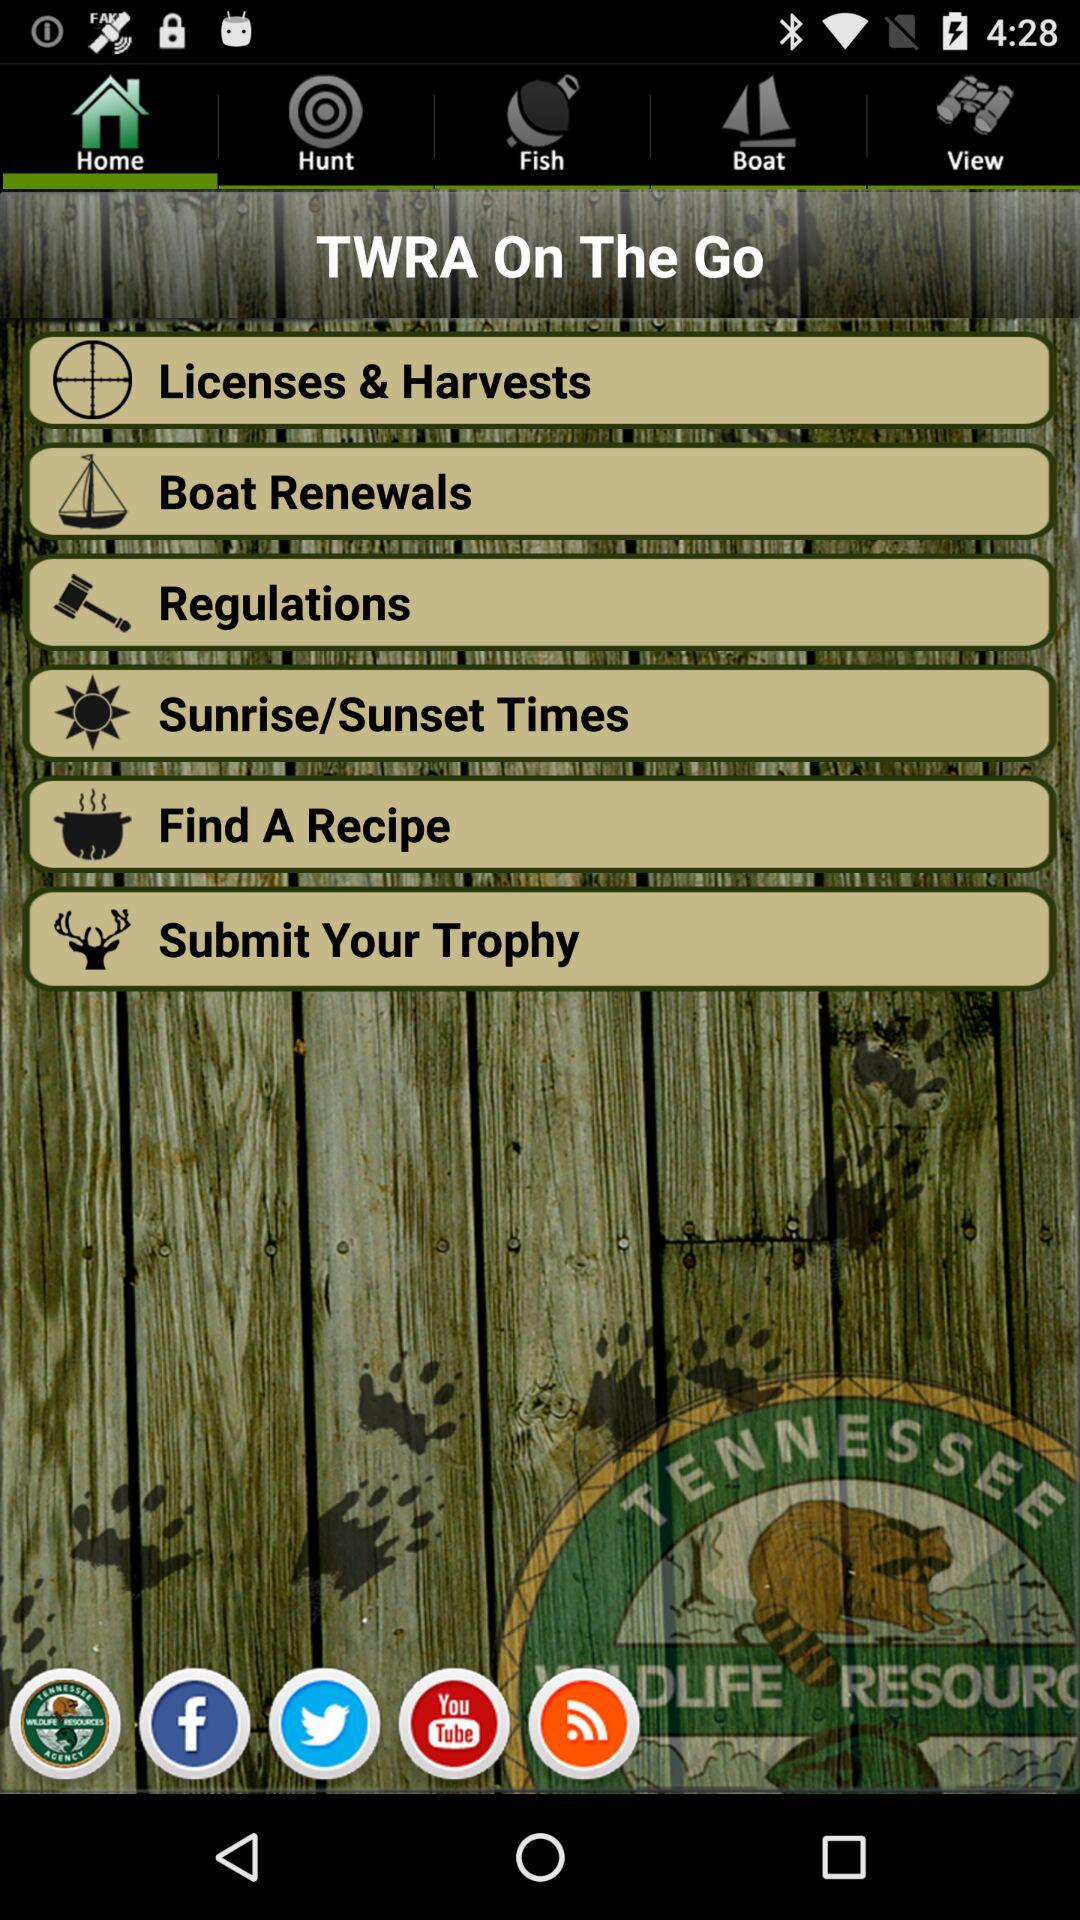Which tab is selected? The selected tab is "Home". 